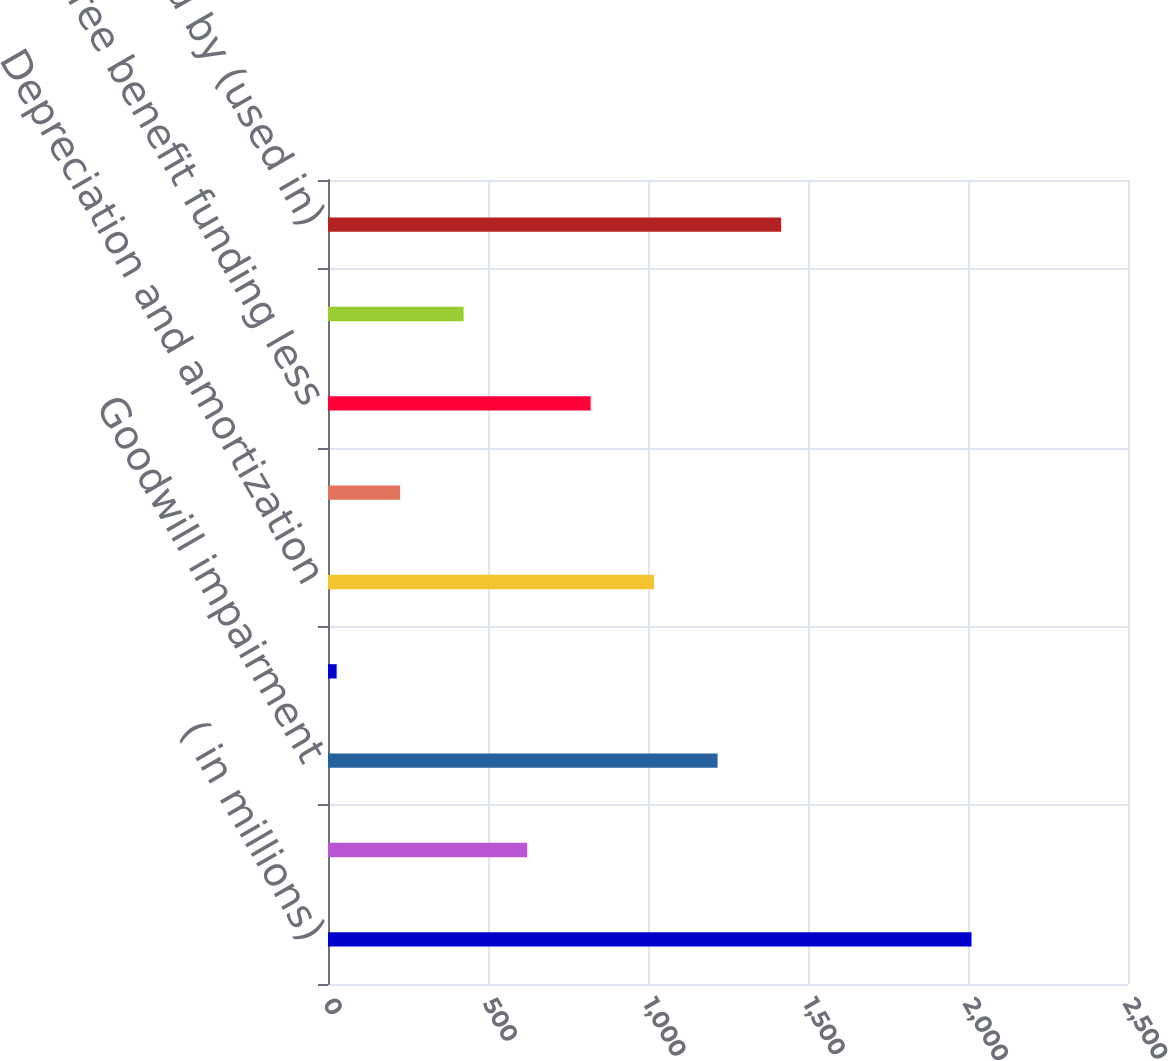Convert chart. <chart><loc_0><loc_0><loc_500><loc_500><bar_chart><fcel>( in millions)<fcel>Net earnings (loss)<fcel>Goodwill impairment<fcel>Deferred income taxes<fcel>Depreciation and amortization<fcel>Stock-based compensation<fcel>Retiree benefit funding less<fcel>Trade working capital decrease<fcel>Net cash provided by (used in)<nl><fcel>2011<fcel>622.2<fcel>1217.4<fcel>27<fcel>1019<fcel>225.4<fcel>820.6<fcel>423.8<fcel>1415.8<nl></chart> 